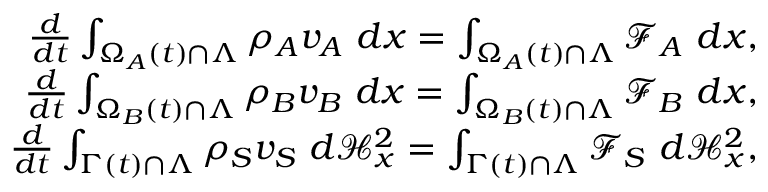Convert formula to latex. <formula><loc_0><loc_0><loc_500><loc_500>\begin{array} { r } { \frac { d } { d t } \int _ { \Omega _ { A } ( t ) \cap \Lambda } \rho _ { A } v _ { A } { \ } d x = \int _ { \Omega _ { A } ( t ) \cap \Lambda } \mathcal { F } _ { A } { \ } d x , } \\ { \frac { d } { d t } \int _ { \Omega _ { B } ( t ) \cap \Lambda } \rho _ { B } v _ { B } { \ } d x = \int _ { \Omega _ { B } ( t ) \cap \Lambda } \mathcal { F } _ { B } { \ } d x , } \\ { \frac { d } { d t } \int _ { \Gamma ( t ) \cap \Lambda } \rho _ { S } v _ { S } { \ } d \mathcal { H } _ { x } ^ { 2 } = \int _ { \Gamma ( t ) \cap \Lambda } \mathcal { F } _ { S } { \ } d \mathcal { H } _ { x } ^ { 2 } , } \end{array}</formula> 